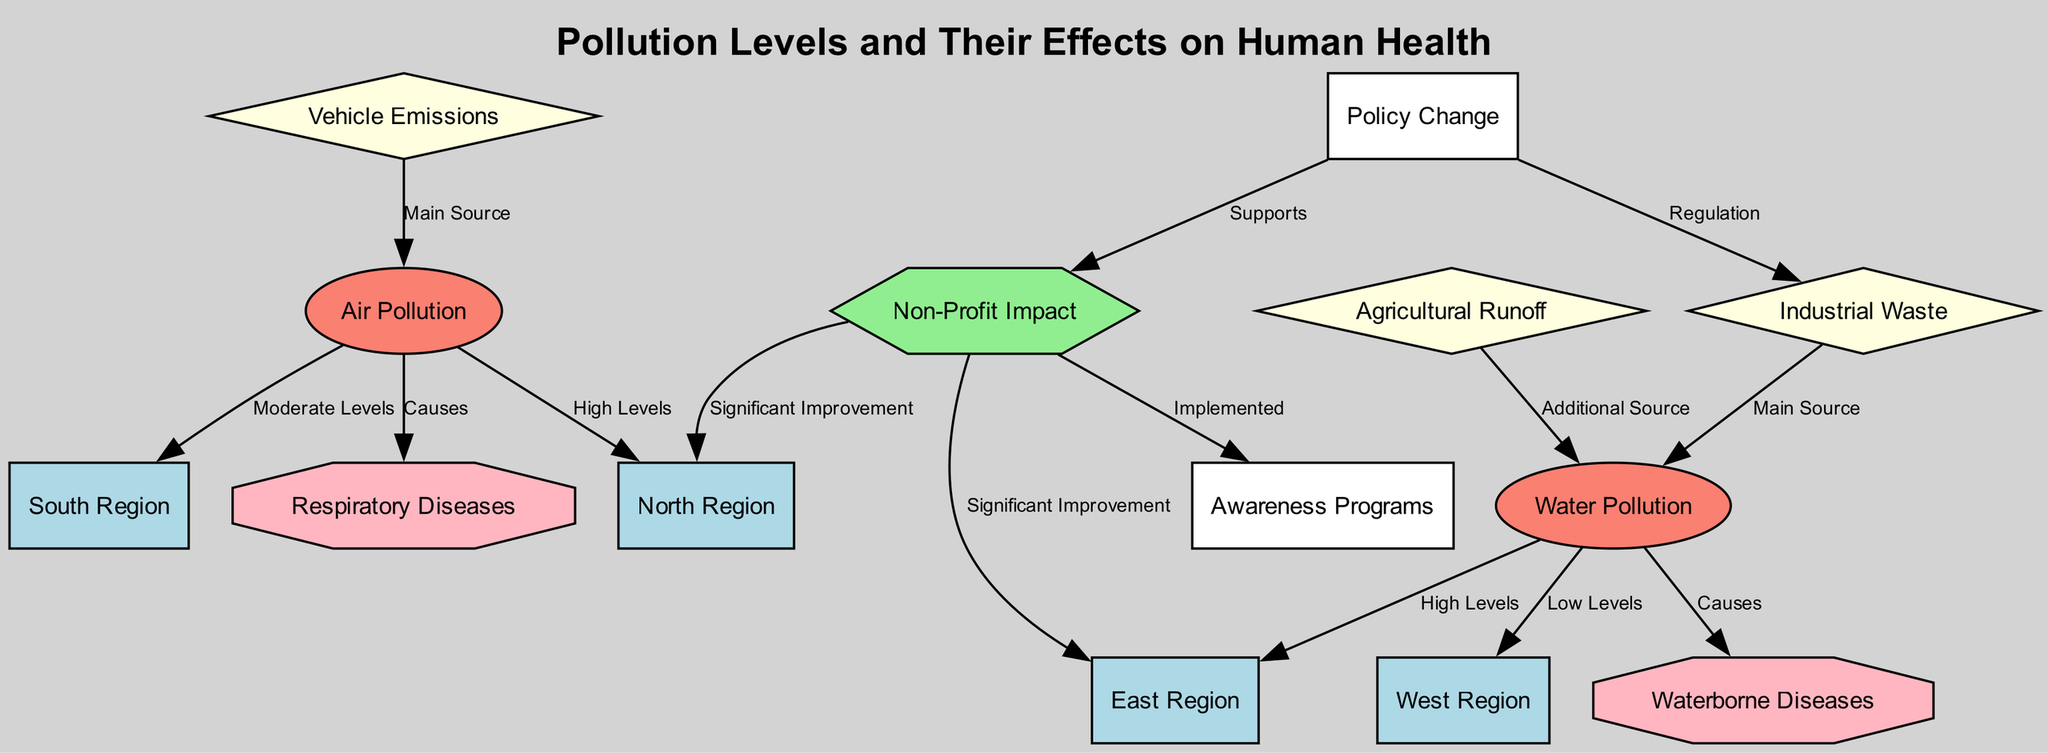What region has high levels of air pollution? The diagram indicates that the North Region is linked to air pollution with a label stating "High Levels." This signifies that out of the regions represented, the North Region experiences the highest measure of air pollution.
Answer: North Region Which source is the main contributor to air pollution? The diagram connects "Vehicle Emissions" as the main source of "Air Pollution," indicated by the directed edge labeled "Main Source." Therefore, vehicle emissions are the primary contributor to air pollution.
Answer: Vehicle Emissions What health risk is caused by water pollution? The node "Waterborne Diseases" is directly connected to "Water Pollution" in the diagram. This indicates that exposure to water pollution leads to the risk of waterborne diseases being a consequence of such pollution.
Answer: Waterborne Diseases How many regions show significant improvement due to non-profit interventions? The diagram links "Non-Profit Impact" to both the North and East regions with edges labeled "Significant Improvement." This indicates that there are two regions with marked improvement as a result of non-profit efforts.
Answer: Two What type of intervention does the non-profit implement? The diagram shows that "Non-Profit Impact" is linked to "Awareness Programs," suggesting that non-profit interventions primarily focus on raising awareness to combat pollution issues as part of their strategies.
Answer: Awareness Programs Which type of pollution is mainly caused by industrial waste? The diagram illustrates that "Industrial Waste" is the main source causing "Water Pollution," specified by the directed edge labeling it as the "Main Source." This indicates that industrial waste significantly contributes to water pollution levels.
Answer: Water Pollution Which region has low levels of water pollution? The diagram identifies that the West Region is linked to water pollution with a label stating "Low Levels." This indicates that out of the regions represented, the West Region faces the least amount of water pollution.
Answer: West Region What supports non-profit impact according to the diagram? The diagram contains a relationship where "Policy Change" supports "Non-Profit Impact," indicated by the edge labeled "Supports." This means policy changes create a favorable environment for non-profit initiatives to thrive and make an impact.
Answer: Policy Change 